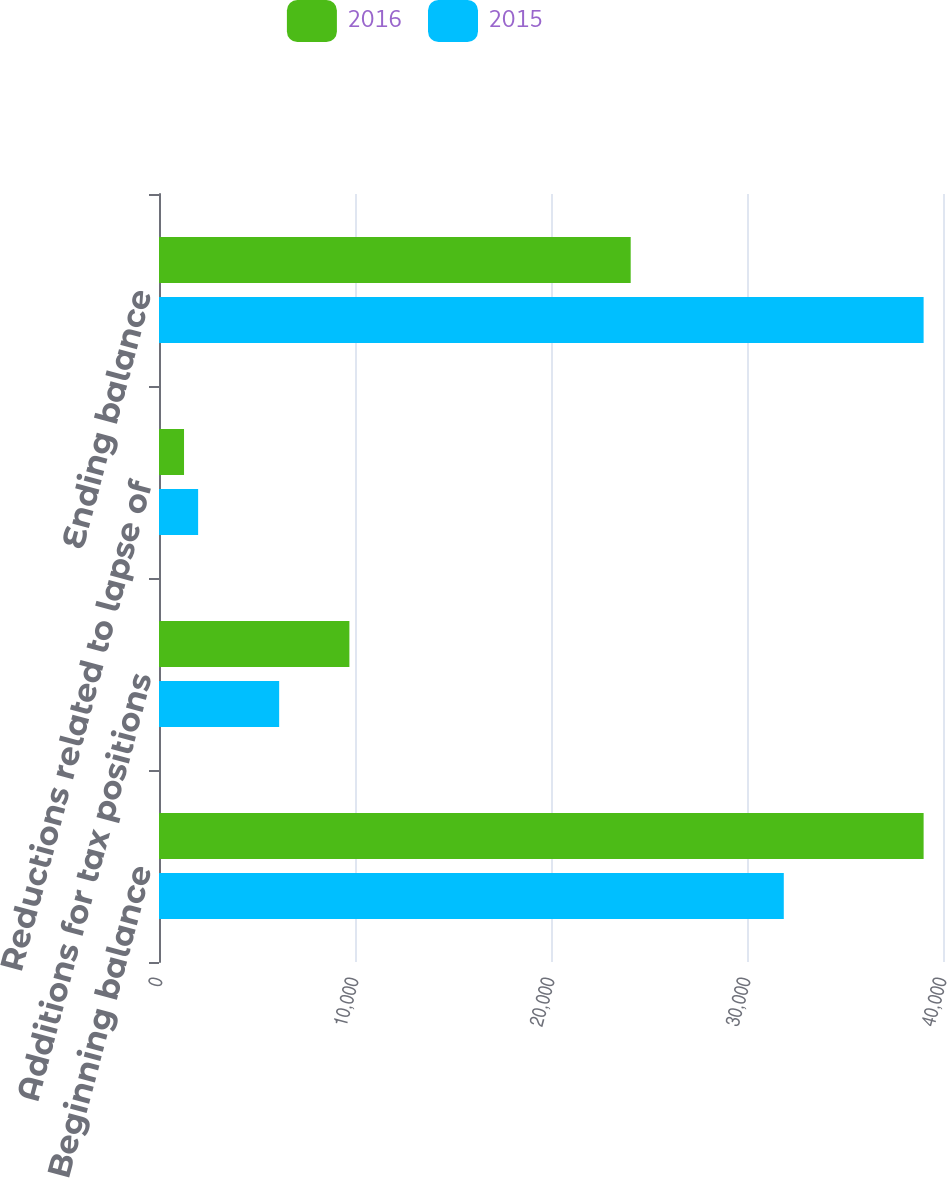Convert chart to OTSL. <chart><loc_0><loc_0><loc_500><loc_500><stacked_bar_chart><ecel><fcel>Beginning balance<fcel>Additions for tax positions<fcel>Reductions related to lapse of<fcel>Ending balance<nl><fcel>2016<fcel>39011<fcel>9714<fcel>1277<fcel>24066<nl><fcel>2015<fcel>31877<fcel>6131<fcel>1996<fcel>39011<nl></chart> 